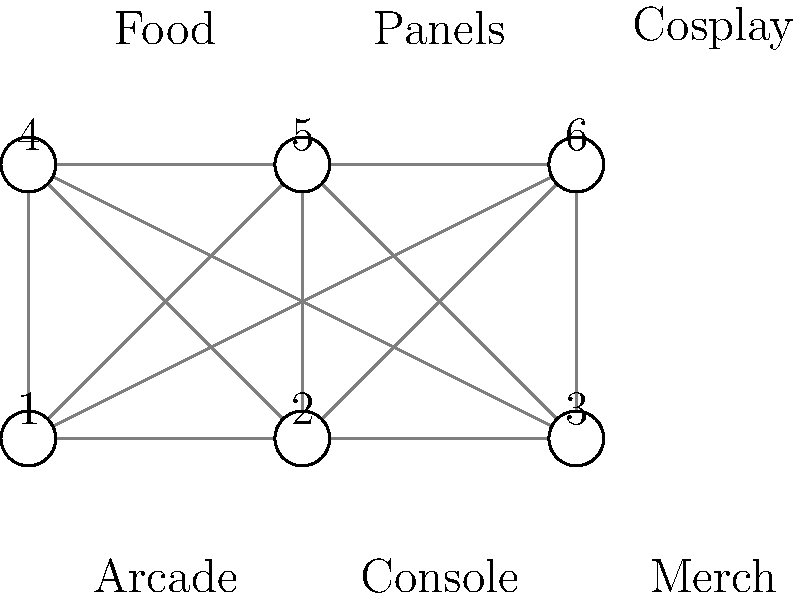You're organizing a retro gaming convention and need to optimize the floor plan layout. The graph represents different areas of the convention (1-Arcade, 2-Console, 3-Merch, 4-Food, 5-Panels, 6-Cosplay), with edges representing possible connections between areas. What is the minimum number of connections needed to ensure all areas are accessible while minimizing crowd congestion? To solve this problem, we need to find the minimum spanning tree of the given graph. This will ensure all areas are connected with the least number of paths, minimizing potential crowd congestion.

Step 1: Identify the number of vertices (areas) in the graph.
There are 6 vertices representing different areas of the convention.

Step 2: Recall the formula for the number of edges in a minimum spanning tree.
For a graph with $n$ vertices, the number of edges in a minimum spanning tree is always $n - 1$.

Step 3: Apply the formula to our specific case.
Number of edges = $n - 1$ = $6 - 1$ = $5$

Therefore, we need a minimum of 5 connections to ensure all areas are accessible while minimizing crowd congestion.

This solution creates a tree-like structure that connects all areas without any cycles, which would create unnecessary pathways and potential congestion points.
Answer: 5 connections 